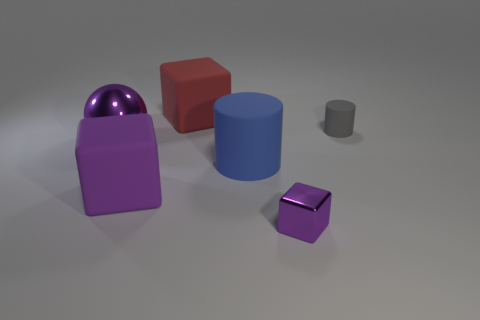There is a tiny gray object; what shape is it?
Provide a short and direct response. Cylinder. How many tiny purple shiny things have the same shape as the blue rubber object?
Ensure brevity in your answer.  0. What number of things are right of the big purple matte cube and in front of the big shiny ball?
Provide a succinct answer. 2. The tiny rubber cylinder has what color?
Offer a very short reply. Gray. Is there a cube made of the same material as the big purple ball?
Ensure brevity in your answer.  Yes. Is there a big object on the right side of the large object that is behind the rubber cylinder to the right of the small metal block?
Offer a terse response. Yes. There is a small gray rubber cylinder; are there any cubes behind it?
Keep it short and to the point. Yes. Is there a big sphere of the same color as the tiny metal object?
Provide a short and direct response. Yes. What number of big objects are either purple matte cubes or purple objects?
Keep it short and to the point. 2. Does the big purple object right of the purple metallic sphere have the same material as the tiny cylinder?
Ensure brevity in your answer.  Yes. 